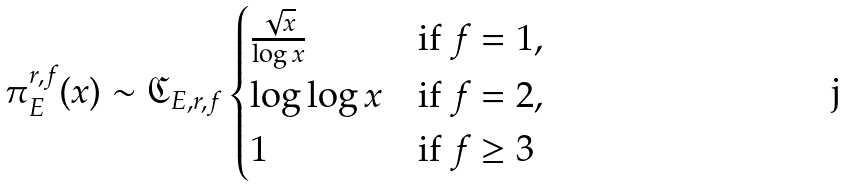Convert formula to latex. <formula><loc_0><loc_0><loc_500><loc_500>\pi _ { E } ^ { r , f } ( x ) \sim \mathfrak { C } _ { E , r , f } \begin{cases} \frac { \sqrt { x } } { \log x } & \text {if } f = 1 , \\ \log \log x & \text {if } f = 2 , \\ 1 & \text {if } f \geq 3 \end{cases}</formula> 